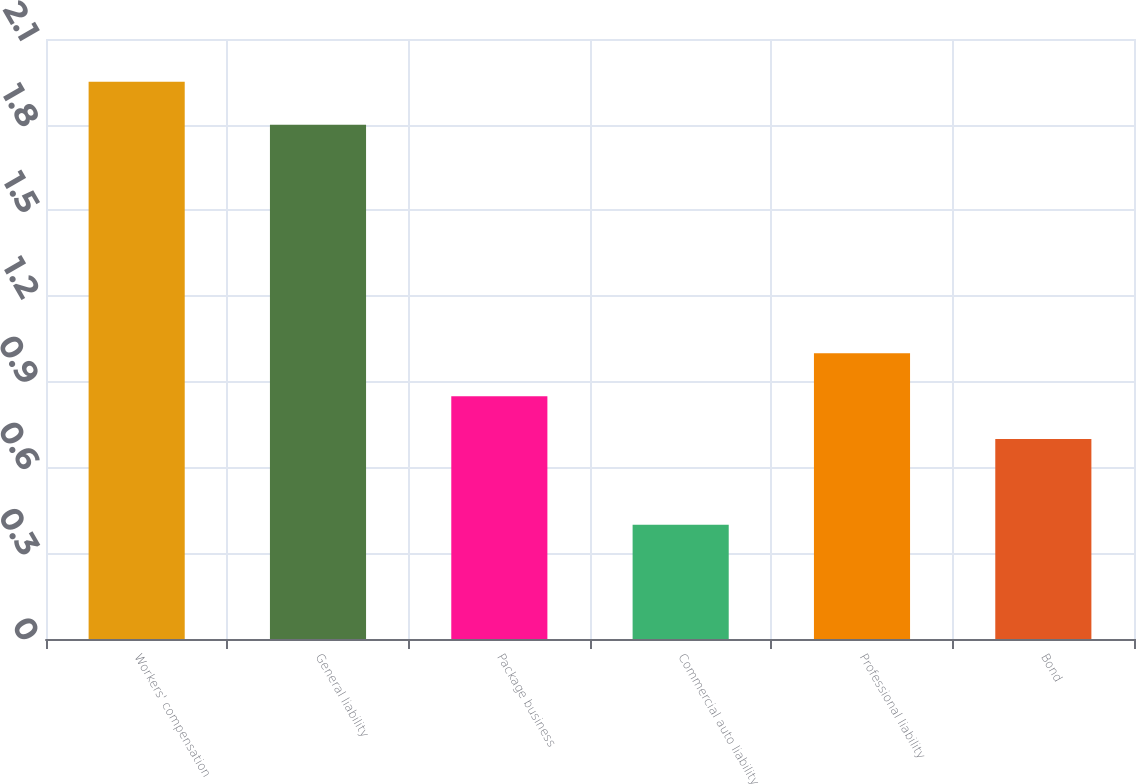Convert chart. <chart><loc_0><loc_0><loc_500><loc_500><bar_chart><fcel>Workers' compensation<fcel>General liability<fcel>Package business<fcel>Commercial auto liability<fcel>Professional liability<fcel>Bond<nl><fcel>1.95<fcel>1.8<fcel>0.85<fcel>0.4<fcel>1<fcel>0.7<nl></chart> 